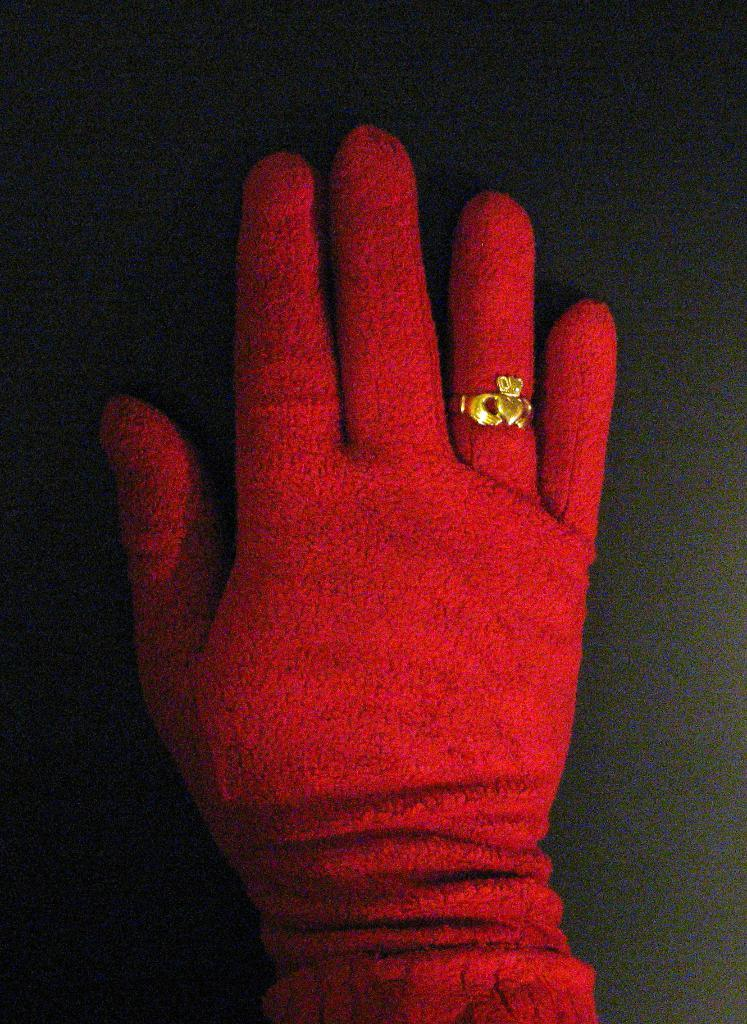What can be seen in the image related to a person's body part? There is a hand in the image. What is the hand wearing? The hand is wearing a red glove. Are there any accessories visible on the hand? Yes, there is a golden ring on one of the fingers of the hand. How many feathers can be seen on the chair in the image? There is no chair present in the image, and therefore no feathers can be observed. 